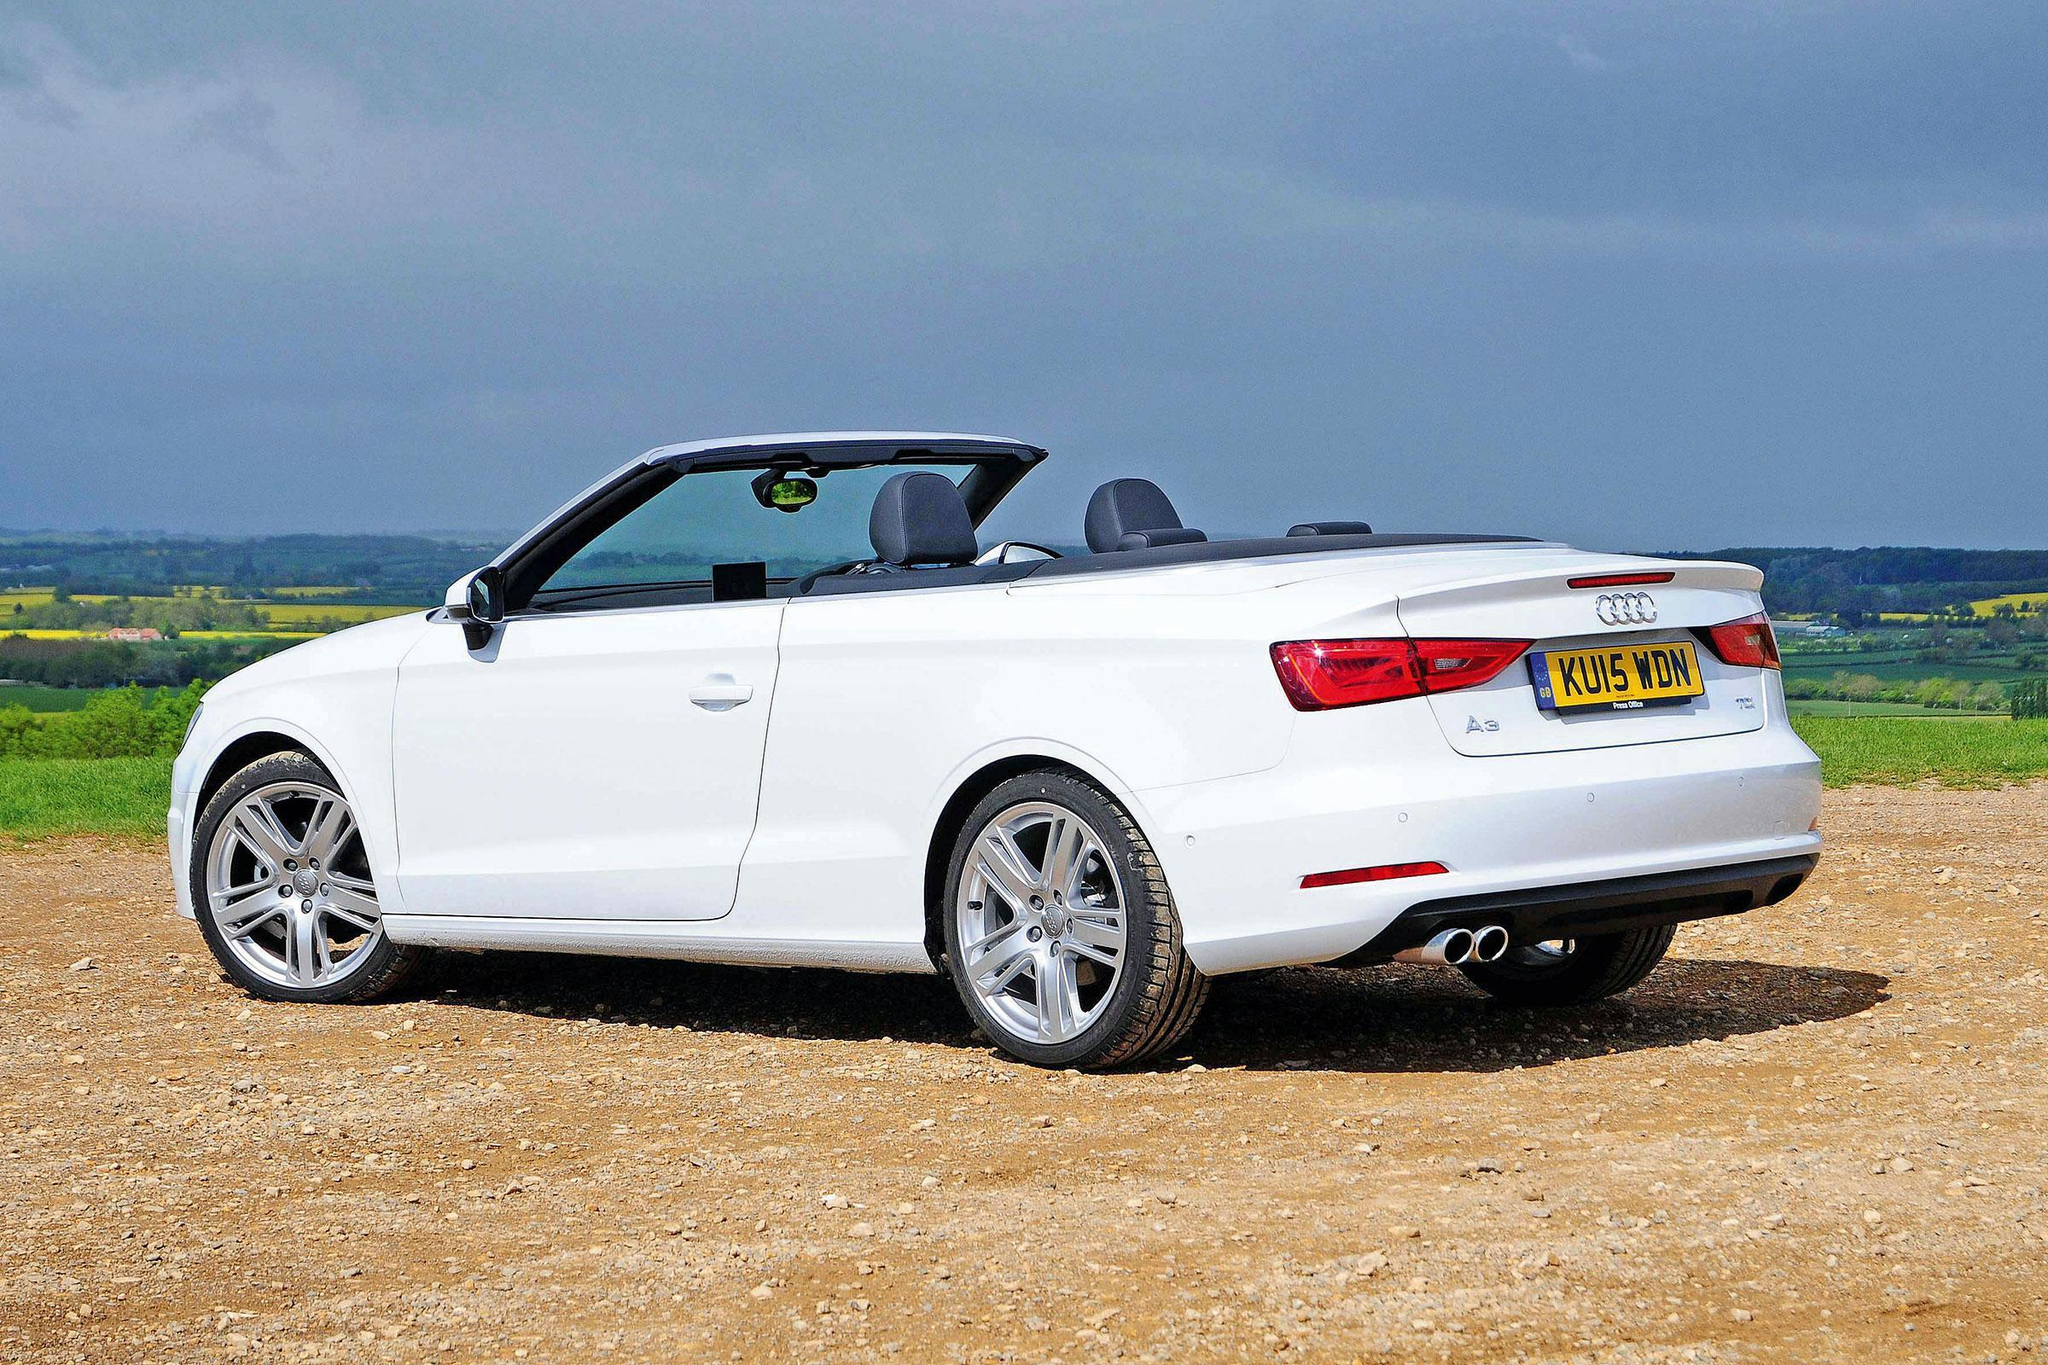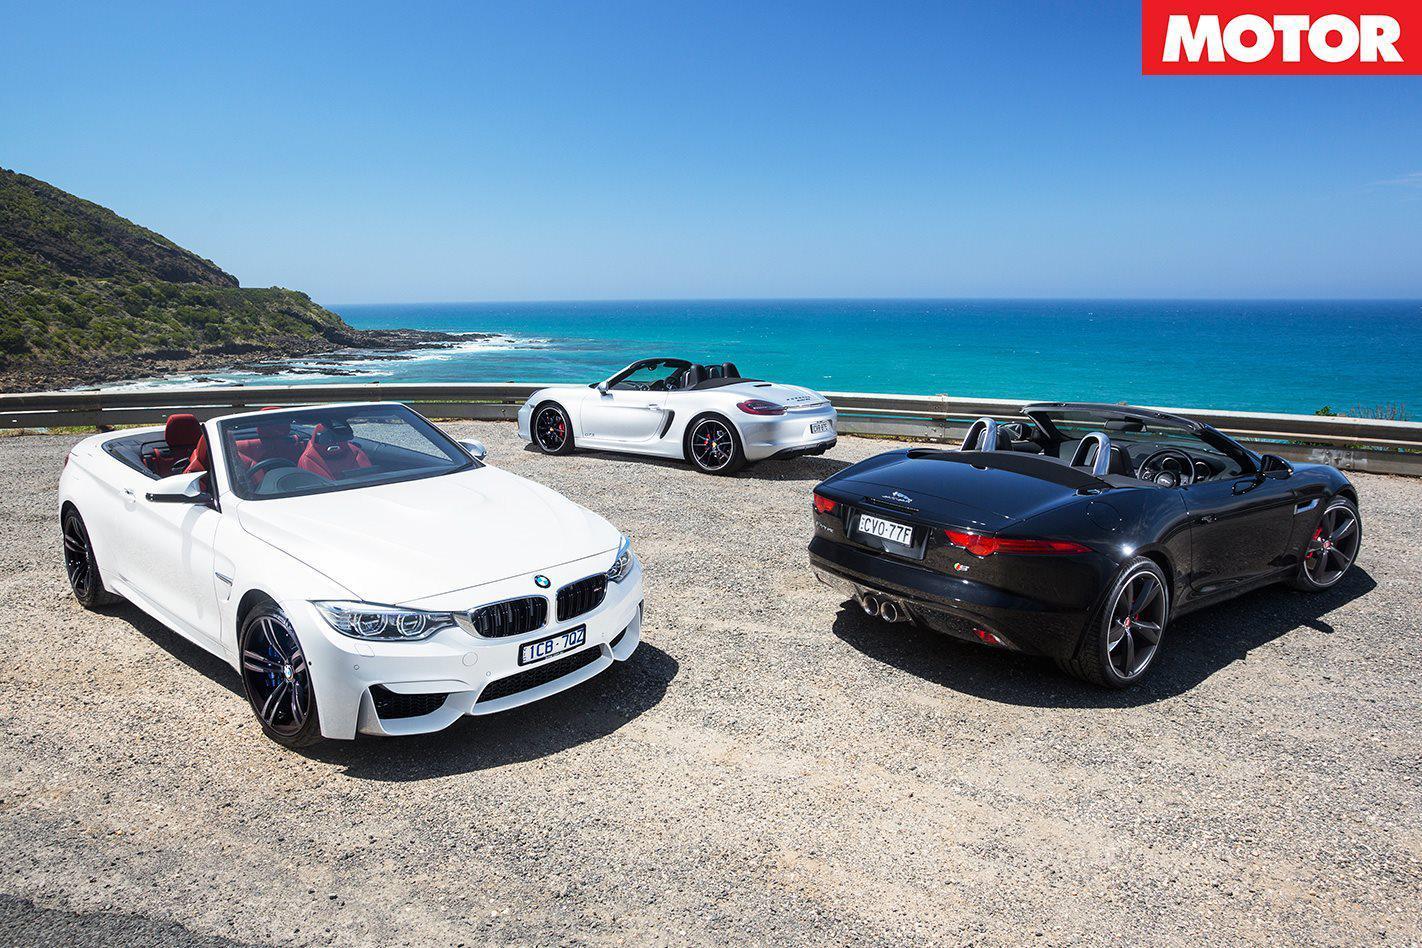The first image is the image on the left, the second image is the image on the right. Examine the images to the left and right. Is the description "One of the cars is black and the rest are white." accurate? Answer yes or no. Yes. 